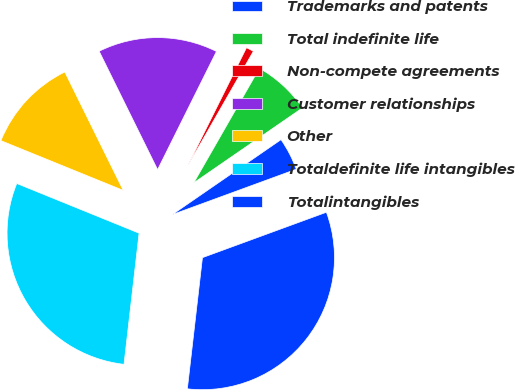<chart> <loc_0><loc_0><loc_500><loc_500><pie_chart><fcel>Trademarks and patents<fcel>Total indefinite life<fcel>Non-compete agreements<fcel>Customer relationships<fcel>Other<fcel>Totaldefinite life intangibles<fcel>Totalintangibles<nl><fcel>4.02%<fcel>7.11%<fcel>0.93%<fcel>14.65%<fcel>11.56%<fcel>29.32%<fcel>32.41%<nl></chart> 